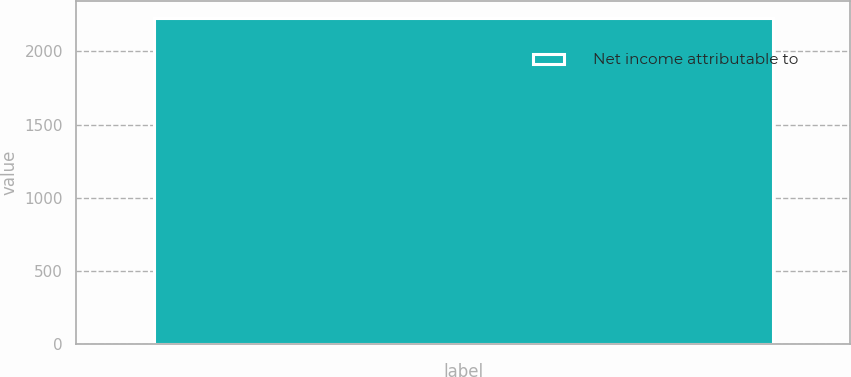<chart> <loc_0><loc_0><loc_500><loc_500><bar_chart><fcel>Net income attributable to<nl><fcel>2232<nl></chart> 